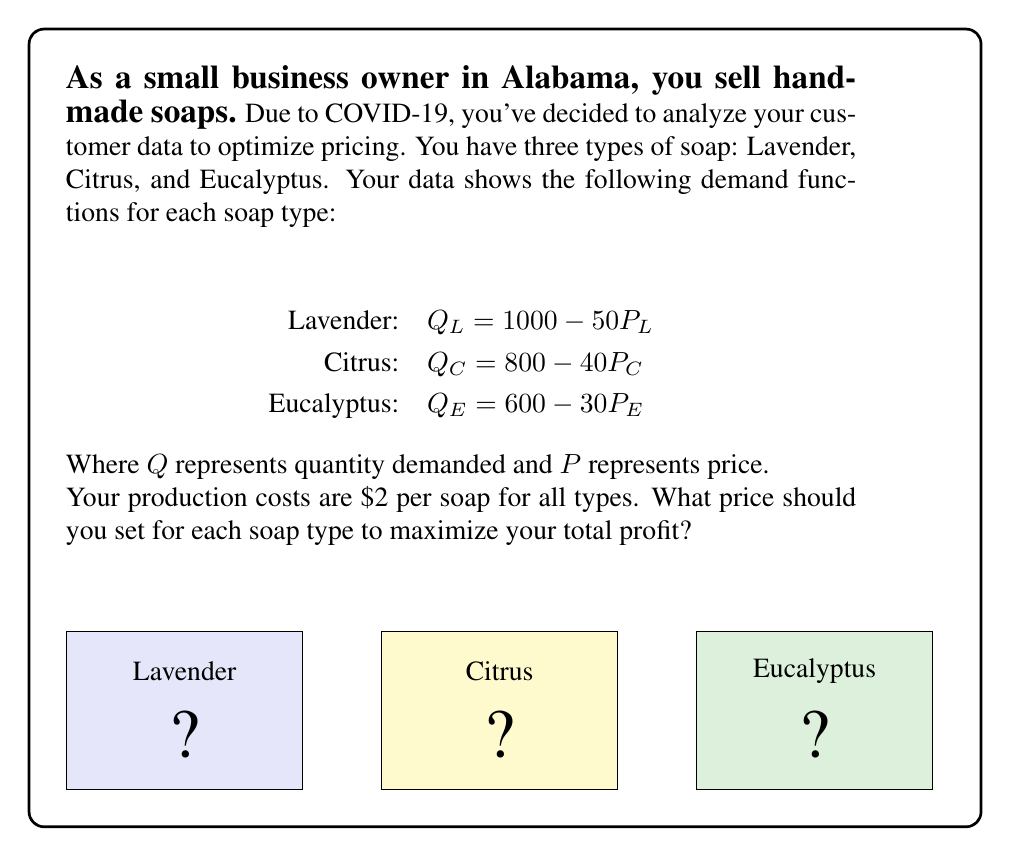Help me with this question. To maximize profit, we need to find the optimal price for each soap type. We'll use the following steps:

1) First, let's write the profit function for each soap type:
   Profit = Revenue - Cost
   $\pi = PQ - 2Q$ (where 2 is the production cost per soap)

2) Substitute the demand functions:
   Lavender: $\pi_L = P_L(1000 - 50P_L) - 2(1000 - 50P_L)$
   Citrus: $\pi_C = P_C(800 - 40P_C) - 2(800 - 40P_C)$
   Eucalyptus: $\pi_E = P_E(600 - 30P_E) - 2(600 - 30P_E)$

3) Expand these equations:
   $\pi_L = 1000P_L - 50P_L^2 - 2000 + 100P_L = -50P_L^2 + 1100P_L - 2000$
   $\pi_C = 800P_C - 40P_C^2 - 1600 + 80P_C = -40P_C^2 + 880P_C - 1600$
   $\pi_E = 600P_E - 30P_E^2 - 1200 + 60P_E = -30P_E^2 + 660P_E - 1200$

4) To find the maximum profit, we differentiate each equation with respect to P and set it to zero:
   $\frac{d\pi_L}{dP_L} = -100P_L + 1100 = 0$
   $\frac{d\pi_C}{dP_C} = -80P_C + 880 = 0$
   $\frac{d\pi_E}{dP_E} = -60P_E + 660 = 0$

5) Solve these equations:
   $P_L = 11$
   $P_C = 11$
   $P_E = 11$

6) To confirm these are maxima, we can check the second derivative is negative:
   $\frac{d^2\pi_L}{dP_L^2} = -100 < 0$
   $\frac{d^2\pi_C}{dP_C^2} = -80 < 0$
   $\frac{d^2\pi_E}{dP_E^2} = -60 < 0$

Therefore, the profit-maximizing price for all three soap types is $11.
Answer: $11 for each soap type 